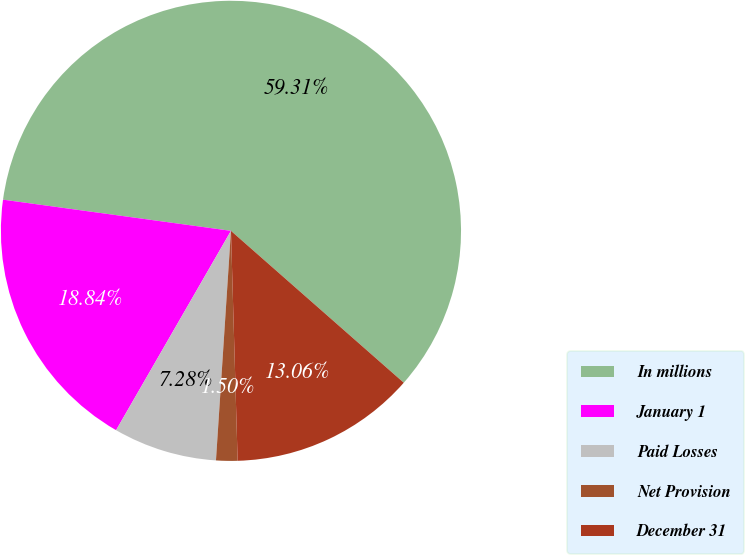Convert chart. <chart><loc_0><loc_0><loc_500><loc_500><pie_chart><fcel>In millions<fcel>January 1<fcel>Paid Losses<fcel>Net Provision<fcel>December 31<nl><fcel>59.3%<fcel>18.84%<fcel>7.28%<fcel>1.5%<fcel>13.06%<nl></chart> 